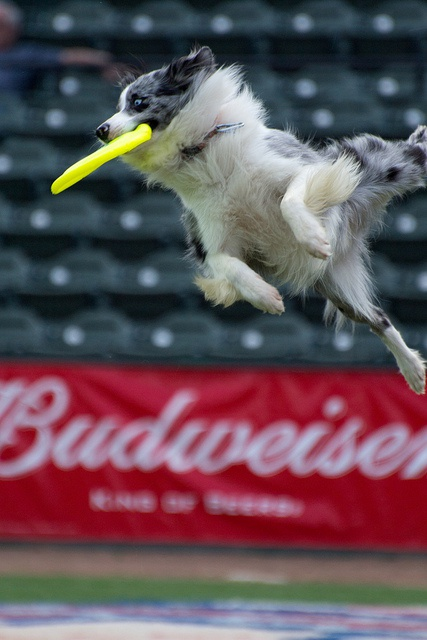Describe the objects in this image and their specific colors. I can see dog in black, darkgray, gray, and lightgray tones and frisbee in black, yellow, khaki, and gray tones in this image. 